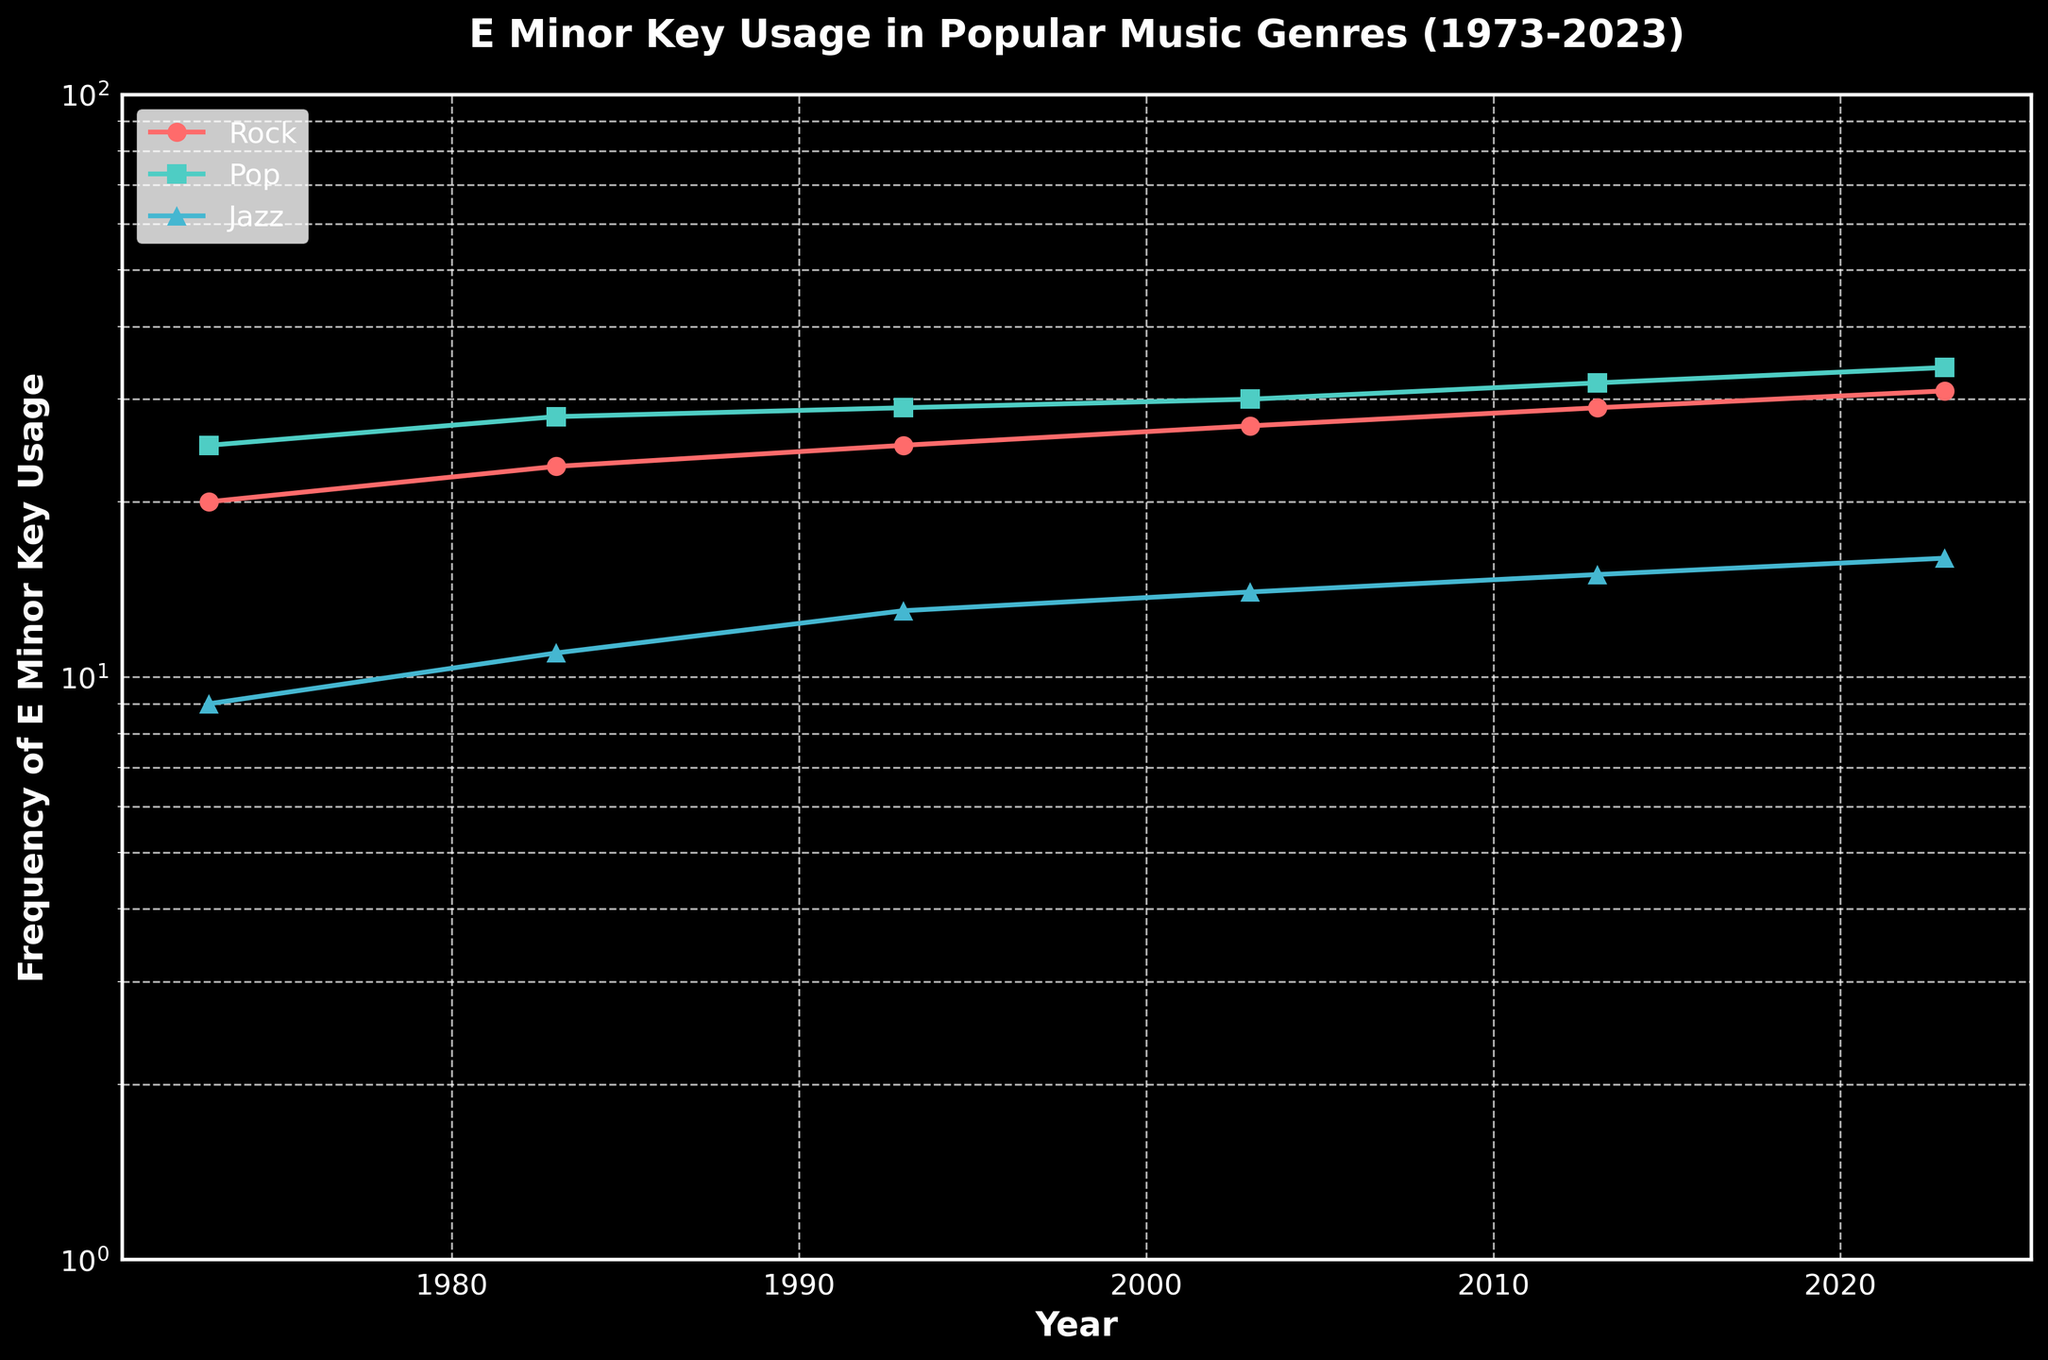what is the title of the figure? Observe the top of the chart where the title is located. The title is usually in larger and bold text.
Answer: E Minor Key Usage in Popular Music Genres (1973-2023) Which genre has shown the highest E Minor key usage in 2023? Look at the data points for the year 2023, the plot with the highest value on the y-axis represents the genre with the highest E Minor key usage.
Answer: Pop By how much has the E Minor key usage in Rock increased from 1973 to 2023? Identify the data points for Rock in 1973 and 2023, then subtract the 1973 value from the 2023 value. In 1973, it was 20 and in 2023, it is 31. Thus, the increase is 31 - 20 = 11.
Answer: 11 What is the trend of E Minor key usage in Jazz from 1973 to 2023? Observe the line specifically for Jazz over the years from 1973 to 2023. Notice if the line increases, decreases, or stays constant.
Answer: Increasing Which genre had the lowest E Minor key usage in 1973? Locate the data points for the year 1973 and determine which has the smallest y-value.
Answer: Jazz Compare the E Minor key usage of Pop and Rock genres in 1983. Which one was higher and by how much? Identify the data points for both Pop (24) and Rock (22) in 1983. Pop is higher. Calculate the difference: 24 - 22 = 2.
Answer: Pop by 2 What does the y-axis represent? The label of the y-axis explains what it measures. This is written next to the axis, usually vertically.
Answer: Frequency of E Minor Key Usage Across all years, which genre shows the most consistent increase in E Minor key usage? Observe the slopes of the lines for each genre. The one with the most steady upward trend would be the most consistent.
Answer: Pop How does the usage of the E Minor key in Rock change between 1993 and 2003? Identify the values for Rock in 1993 (25) and 2003 (27), and calculate the difference: 27 - 25. This indicates an increase of 2.
Answer: Increased by 2 What is the range of E Minor key usage in Pop in 2023? Given the y-scale is logarithmic, identify the minimum and maximum values around Pop in 2023. The values are from 32 to 34.
Answer: 32-34 